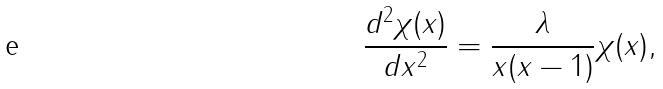Convert formula to latex. <formula><loc_0><loc_0><loc_500><loc_500>\frac { d ^ { 2 } \chi ( x ) } { d x ^ { 2 } } = \frac { \lambda } { x ( x - 1 ) } \chi ( x ) ,</formula> 